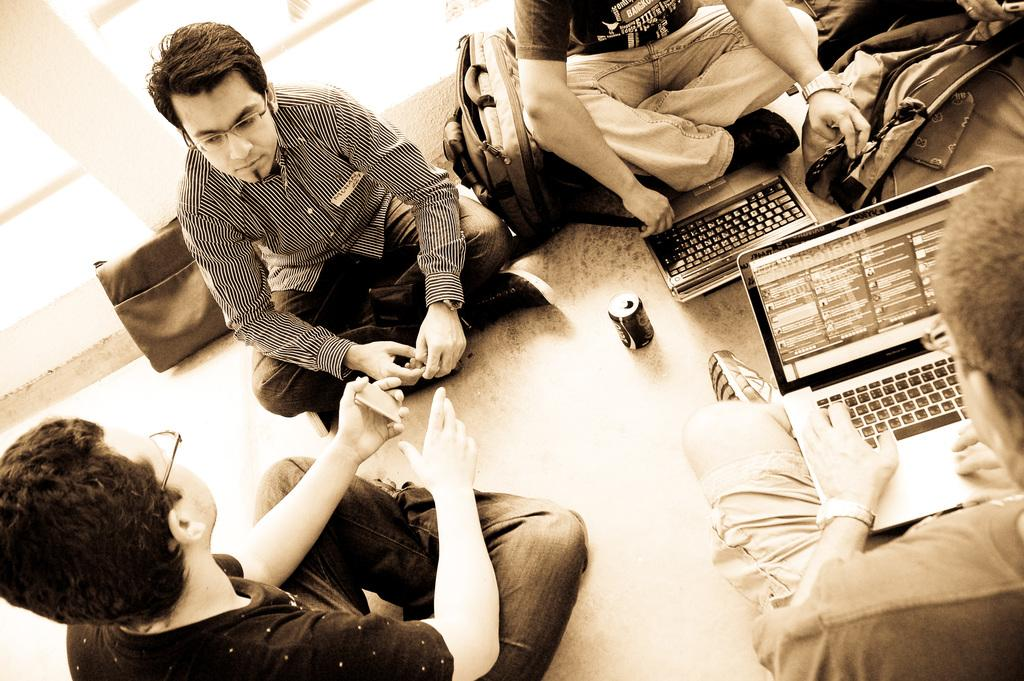What are the people in the image doing? The people in the image are sitting in the foreground. Where are the people sitting? The people are sitting on the floor. What items can be seen in the image besides the people? There are two bags, laptops, and a tin in the image. Can you describe the object in the right top corner of the image? Unfortunately, the facts provided do not give enough information to describe the object in the right top corner. What type of hose is being used for breakfast in the image? There is no hose or breakfast present in the image. What experience can be gained from the people sitting in the image? The facts provided do not give enough information to determine any experience that can be gained from the people sitting in the image. 